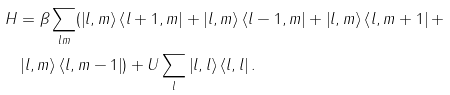<formula> <loc_0><loc_0><loc_500><loc_500>H & = \beta \sum _ { l m } ( \left | l , m \right \rangle \left \langle l + 1 , m \right | + \left | l , m \right \rangle \left \langle l - 1 , m \right | + \left | l , m \right \rangle \left \langle l , m + 1 \right | + \\ & \left | l , m \right \rangle \left \langle l , m - 1 \right | ) + U \sum _ { l } \left | l , l \right \rangle \left \langle l , l \right | .</formula> 